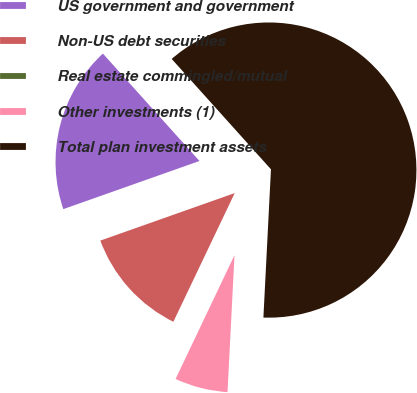<chart> <loc_0><loc_0><loc_500><loc_500><pie_chart><fcel>US government and government<fcel>Non-US debt securities<fcel>Real estate commingled/mutual<fcel>Other investments (1)<fcel>Total plan investment assets<nl><fcel>18.75%<fcel>12.51%<fcel>0.01%<fcel>6.26%<fcel>62.47%<nl></chart> 